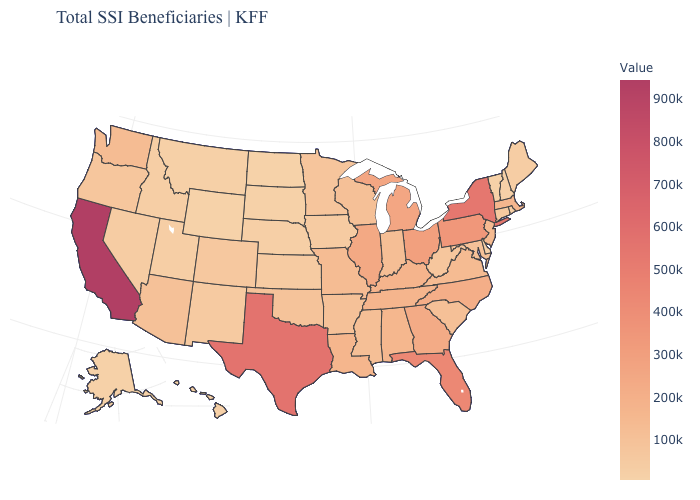Is the legend a continuous bar?
Short answer required. Yes. Does Wyoming have the lowest value in the USA?
Short answer required. Yes. Does Kentucky have a higher value than New Hampshire?
Answer briefly. Yes. Does Wyoming have the lowest value in the USA?
Concise answer only. Yes. Is the legend a continuous bar?
Short answer required. Yes. Which states hav the highest value in the Northeast?
Be succinct. New York. Does Wyoming have the highest value in the West?
Quick response, please. No. 